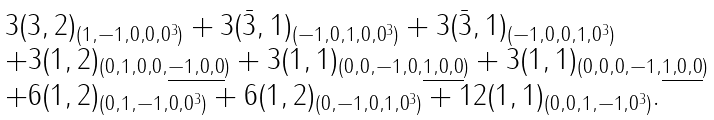Convert formula to latex. <formula><loc_0><loc_0><loc_500><loc_500>\begin{array} { l } 3 ( 3 , 2 ) _ { ( 1 , - 1 , 0 , 0 , 0 ^ { 3 } ) } + 3 ( \bar { 3 } , 1 ) _ { ( - 1 , 0 , 1 , 0 , 0 ^ { 3 } ) } + 3 ( \bar { 3 } , 1 ) _ { ( - 1 , 0 , 0 , 1 , 0 ^ { 3 } ) } \\ + 3 ( 1 , 2 ) _ { ( 0 , 1 , 0 , 0 , \underline { - 1 , 0 , 0 } ) } + 3 ( 1 , 1 ) _ { ( 0 , 0 , - 1 , 0 , \underline { 1 , 0 , 0 } ) } + 3 ( 1 , 1 ) _ { ( 0 , 0 , 0 , - 1 , \underline { 1 , 0 , 0 } ) } \\ + 6 ( 1 , 2 ) _ { ( 0 , 1 , - 1 , 0 , 0 ^ { 3 } ) } + 6 ( 1 , 2 ) _ { ( 0 , - 1 , 0 , 1 , 0 ^ { 3 } ) } + 1 2 ( 1 , 1 ) _ { ( 0 , 0 , 1 , - 1 , 0 ^ { 3 } ) } . \\ \end{array}</formula> 